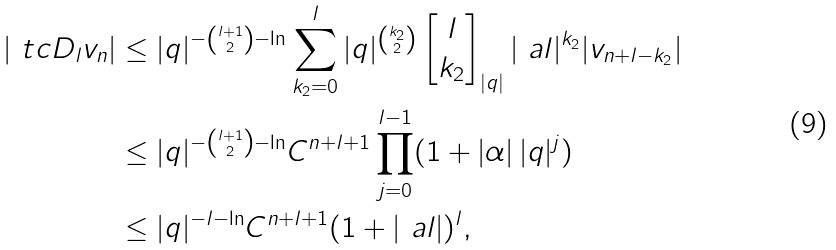Convert formula to latex. <formula><loc_0><loc_0><loc_500><loc_500>| \ t c D _ { l } v _ { n } | & \leq | q | ^ { - \binom { l + 1 } 2 - \ln } \sum _ { k _ { 2 } = 0 } ^ { l } | q | ^ { \binom { k _ { 2 } } 2 } \begin{bmatrix} l \\ k _ { 2 } \end{bmatrix} _ { | q | } | \ a l | ^ { k _ { 2 } } | v _ { n + l - k _ { 2 } } | \\ & \leq | q | ^ { - \binom { l + 1 } 2 - \ln } C ^ { n + l + 1 } \prod _ { j = 0 } ^ { l - 1 } ( 1 + | \alpha | \, | q | ^ { j } ) \\ & \leq | q | ^ { - l - \ln } C ^ { n + l + 1 } ( 1 + | \ a l | ) ^ { l } ,</formula> 